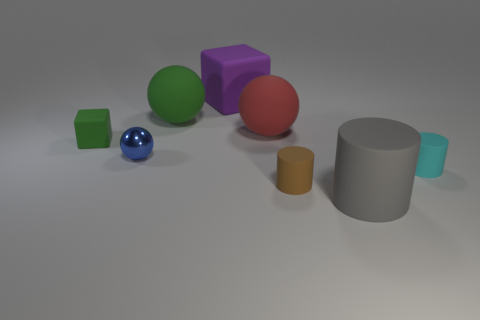How many objects are either large gray cubes or small objects that are behind the small brown cylinder?
Offer a terse response. 3. The rubber cube that is right of the small green rubber thing that is on the left side of the large gray rubber object is what color?
Your answer should be compact. Purple. What number of other things are the same material as the big purple block?
Your answer should be compact. 6. What number of rubber objects are either big purple blocks or cylinders?
Offer a very short reply. 4. What is the color of the other big matte object that is the same shape as the large red object?
Your answer should be very brief. Green. What number of objects are purple matte objects or rubber objects?
Your answer should be compact. 7. What is the shape of the cyan thing that is the same material as the big red thing?
Offer a very short reply. Cylinder. What number of tiny objects are either purple things or matte objects?
Offer a very short reply. 3. What number of other things are there of the same color as the small cube?
Provide a short and direct response. 1. How many things are to the left of the rubber cylinder that is behind the tiny cylinder on the left side of the cyan rubber thing?
Give a very brief answer. 7. 